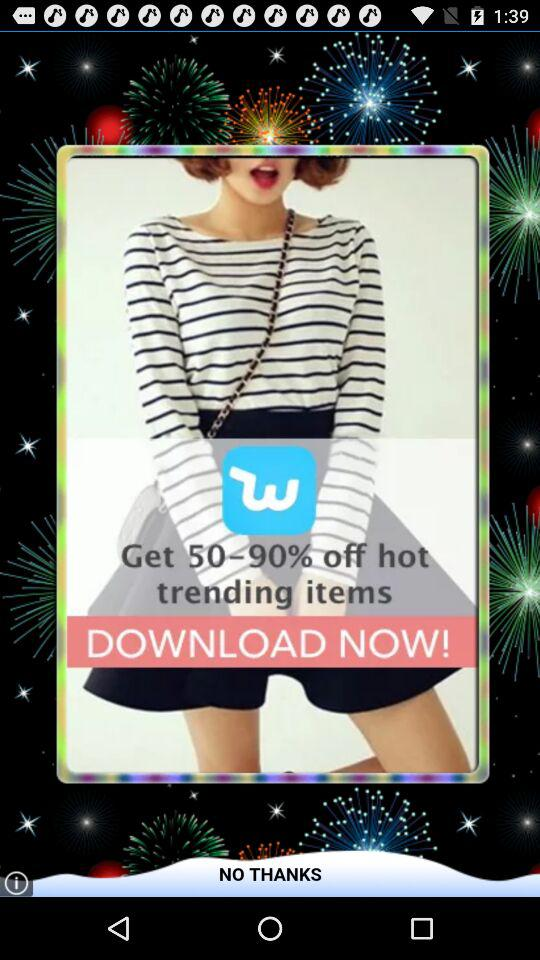How much is off for the hot trending items? The off is 50-90%. 